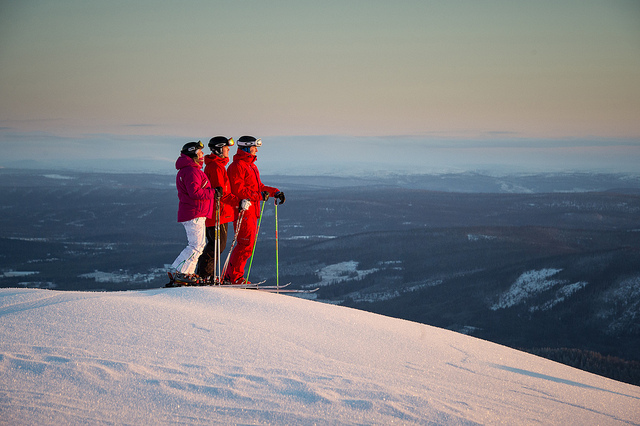How many people are there? 3 